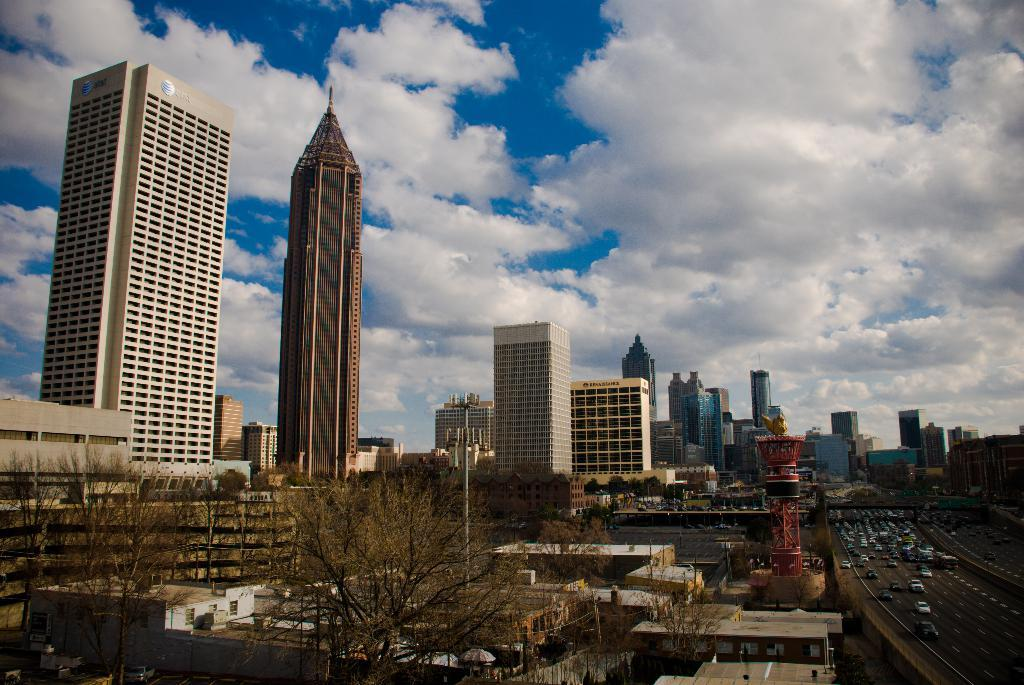What is located in the center of the image? There are buildings in the center of the image. What type of natural elements can be seen in the image? There are trees in the image. What mode of transportation can be seen on the road in the image? There are vehicles on the road in the image. What is visible in the background of the image? The sky is visible in the background of the image. What can be observed in the sky? Clouds are present in the sky. Can you see any deer in the image? There are no deer present in the image. What type of cloth is draped over the buildings in the image? There is no cloth draped over the buildings in the image; only the buildings, trees, vehicles, and sky are visible. 